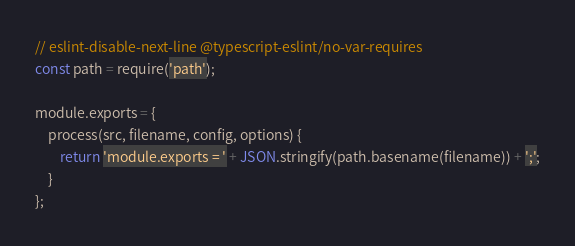Convert code to text. <code><loc_0><loc_0><loc_500><loc_500><_JavaScript_>// eslint-disable-next-line @typescript-eslint/no-var-requires
const path = require('path');

module.exports = {
    process(src, filename, config, options) {
        return 'module.exports = ' + JSON.stringify(path.basename(filename)) + ';';
    }
};
</code> 